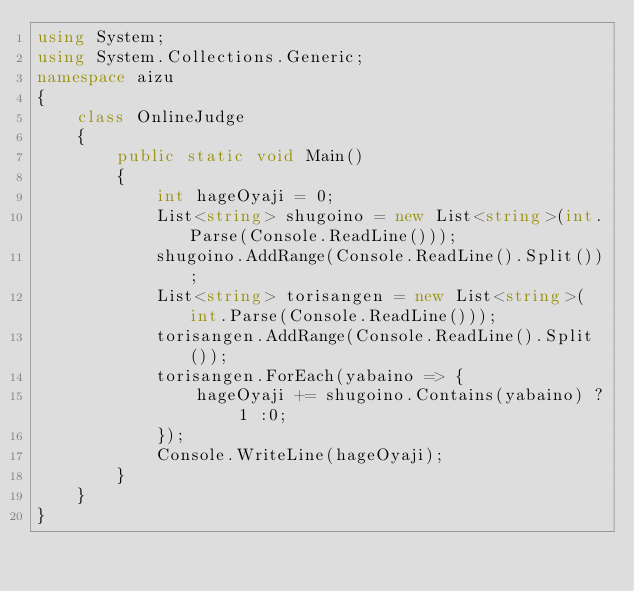Convert code to text. <code><loc_0><loc_0><loc_500><loc_500><_C#_>using System;
using System.Collections.Generic;
namespace aizu
{
    class OnlineJudge
    {
        public static void Main()
        {
            int hageOyaji = 0;
            List<string> shugoino = new List<string>(int.Parse(Console.ReadLine()));
            shugoino.AddRange(Console.ReadLine().Split());
            List<string> torisangen = new List<string>(int.Parse(Console.ReadLine()));
            torisangen.AddRange(Console.ReadLine().Split());
            torisangen.ForEach(yabaino => {
                hageOyaji += shugoino.Contains(yabaino) ? 1 :0;
            });
            Console.WriteLine(hageOyaji);
        }
    }
}</code> 